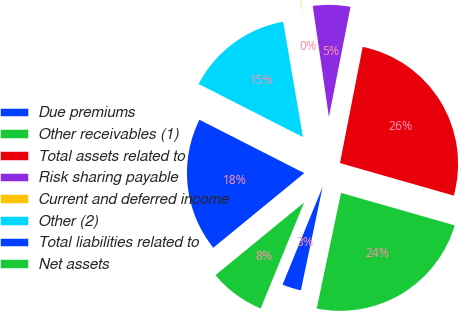<chart> <loc_0><loc_0><loc_500><loc_500><pie_chart><fcel>Due premiums<fcel>Other receivables (1)<fcel>Total assets related to<fcel>Risk sharing payable<fcel>Current and deferred income<fcel>Other (2)<fcel>Total liabilities related to<fcel>Net assets<nl><fcel>2.89%<fcel>23.87%<fcel>26.36%<fcel>5.38%<fcel>0.4%<fcel>14.8%<fcel>18.43%<fcel>7.88%<nl></chart> 